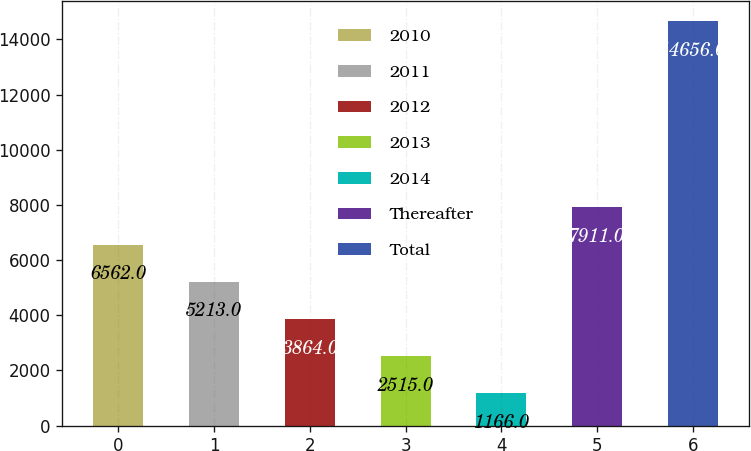Convert chart to OTSL. <chart><loc_0><loc_0><loc_500><loc_500><bar_chart><fcel>2010<fcel>2011<fcel>2012<fcel>2013<fcel>2014<fcel>Thereafter<fcel>Total<nl><fcel>6562<fcel>5213<fcel>3864<fcel>2515<fcel>1166<fcel>7911<fcel>14656<nl></chart> 